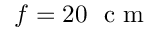Convert formula to latex. <formula><loc_0><loc_0><loc_500><loc_500>f = 2 0 c m</formula> 